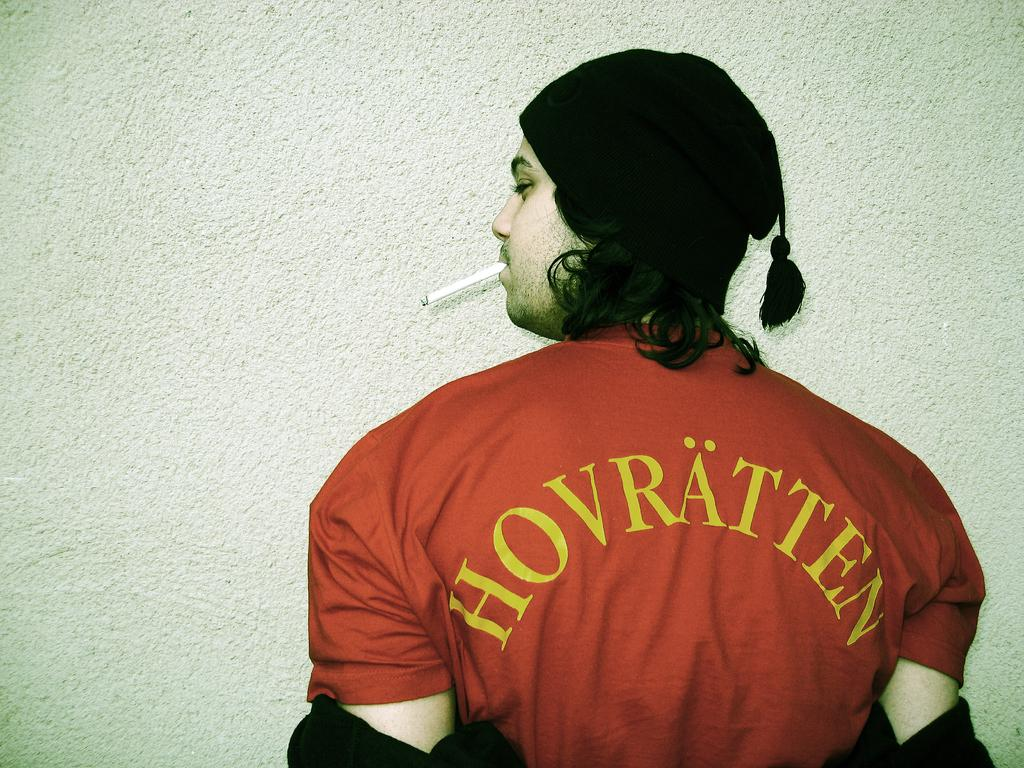<image>
Offer a succinct explanation of the picture presented. A man standing with his back to the camera and a shirt reading hovratten 